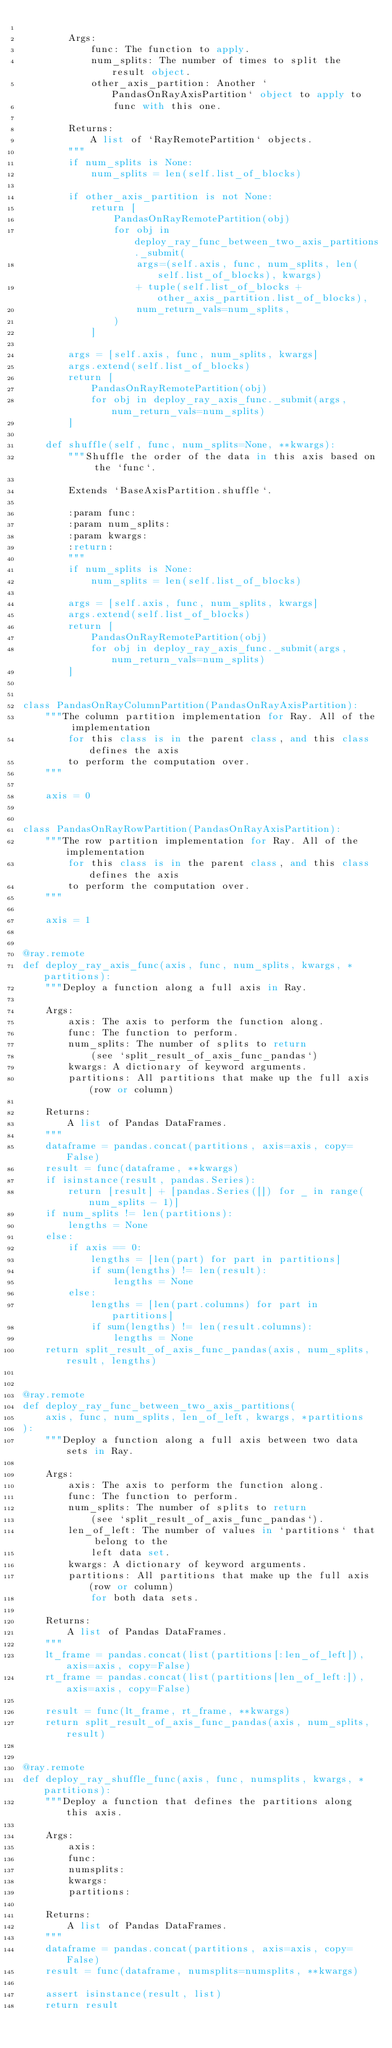<code> <loc_0><loc_0><loc_500><loc_500><_Python_>
        Args:
            func: The function to apply.
            num_splits: The number of times to split the result object.
            other_axis_partition: Another `PandasOnRayAxisPartition` object to apply to
                func with this one.

        Returns:
            A list of `RayRemotePartition` objects.
        """
        if num_splits is None:
            num_splits = len(self.list_of_blocks)

        if other_axis_partition is not None:
            return [
                PandasOnRayRemotePartition(obj)
                for obj in deploy_ray_func_between_two_axis_partitions._submit(
                    args=(self.axis, func, num_splits, len(self.list_of_blocks), kwargs)
                    + tuple(self.list_of_blocks + other_axis_partition.list_of_blocks),
                    num_return_vals=num_splits,
                )
            ]

        args = [self.axis, func, num_splits, kwargs]
        args.extend(self.list_of_blocks)
        return [
            PandasOnRayRemotePartition(obj)
            for obj in deploy_ray_axis_func._submit(args, num_return_vals=num_splits)
        ]

    def shuffle(self, func, num_splits=None, **kwargs):
        """Shuffle the order of the data in this axis based on the `func`.

        Extends `BaseAxisPartition.shuffle`.

        :param func:
        :param num_splits:
        :param kwargs:
        :return:
        """
        if num_splits is None:
            num_splits = len(self.list_of_blocks)

        args = [self.axis, func, num_splits, kwargs]
        args.extend(self.list_of_blocks)
        return [
            PandasOnRayRemotePartition(obj)
            for obj in deploy_ray_axis_func._submit(args, num_return_vals=num_splits)
        ]


class PandasOnRayColumnPartition(PandasOnRayAxisPartition):
    """The column partition implementation for Ray. All of the implementation
        for this class is in the parent class, and this class defines the axis
        to perform the computation over.
    """

    axis = 0


class PandasOnRayRowPartition(PandasOnRayAxisPartition):
    """The row partition implementation for Ray. All of the implementation
        for this class is in the parent class, and this class defines the axis
        to perform the computation over.
    """

    axis = 1


@ray.remote
def deploy_ray_axis_func(axis, func, num_splits, kwargs, *partitions):
    """Deploy a function along a full axis in Ray.

    Args:
        axis: The axis to perform the function along.
        func: The function to perform.
        num_splits: The number of splits to return
            (see `split_result_of_axis_func_pandas`)
        kwargs: A dictionary of keyword arguments.
        partitions: All partitions that make up the full axis (row or column)

    Returns:
        A list of Pandas DataFrames.
    """
    dataframe = pandas.concat(partitions, axis=axis, copy=False)
    result = func(dataframe, **kwargs)
    if isinstance(result, pandas.Series):
        return [result] + [pandas.Series([]) for _ in range(num_splits - 1)]
    if num_splits != len(partitions):
        lengths = None
    else:
        if axis == 0:
            lengths = [len(part) for part in partitions]
            if sum(lengths) != len(result):
                lengths = None
        else:
            lengths = [len(part.columns) for part in partitions]
            if sum(lengths) != len(result.columns):
                lengths = None
    return split_result_of_axis_func_pandas(axis, num_splits, result, lengths)


@ray.remote
def deploy_ray_func_between_two_axis_partitions(
    axis, func, num_splits, len_of_left, kwargs, *partitions
):
    """Deploy a function along a full axis between two data sets in Ray.

    Args:
        axis: The axis to perform the function along.
        func: The function to perform.
        num_splits: The number of splits to return
            (see `split_result_of_axis_func_pandas`).
        len_of_left: The number of values in `partitions` that belong to the
            left data set.
        kwargs: A dictionary of keyword arguments.
        partitions: All partitions that make up the full axis (row or column)
            for both data sets.

    Returns:
        A list of Pandas DataFrames.
    """
    lt_frame = pandas.concat(list(partitions[:len_of_left]), axis=axis, copy=False)
    rt_frame = pandas.concat(list(partitions[len_of_left:]), axis=axis, copy=False)

    result = func(lt_frame, rt_frame, **kwargs)
    return split_result_of_axis_func_pandas(axis, num_splits, result)


@ray.remote
def deploy_ray_shuffle_func(axis, func, numsplits, kwargs, *partitions):
    """Deploy a function that defines the partitions along this axis.

    Args:
        axis:
        func:
        numsplits:
        kwargs:
        partitions:

    Returns:
        A list of Pandas DataFrames.
    """
    dataframe = pandas.concat(partitions, axis=axis, copy=False)
    result = func(dataframe, numsplits=numsplits, **kwargs)

    assert isinstance(result, list)
    return result
</code> 